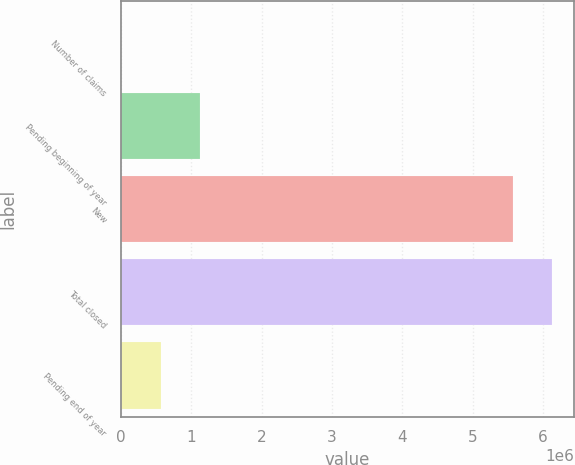Convert chart. <chart><loc_0><loc_0><loc_500><loc_500><bar_chart><fcel>Number of claims<fcel>Pending beginning of year<fcel>New<fcel>Total closed<fcel>Pending end of year<nl><fcel>2010<fcel>1.12584e+06<fcel>5.5712e+06<fcel>6.13311e+06<fcel>563925<nl></chart> 